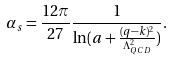<formula> <loc_0><loc_0><loc_500><loc_500>\alpha _ { s } = \frac { 1 2 \pi } { 2 7 } \frac { 1 } { \ln ( a + \frac { ( q - k ) ^ { 2 } } { \Lambda ^ { 2 } _ { Q C D } } ) } .</formula> 